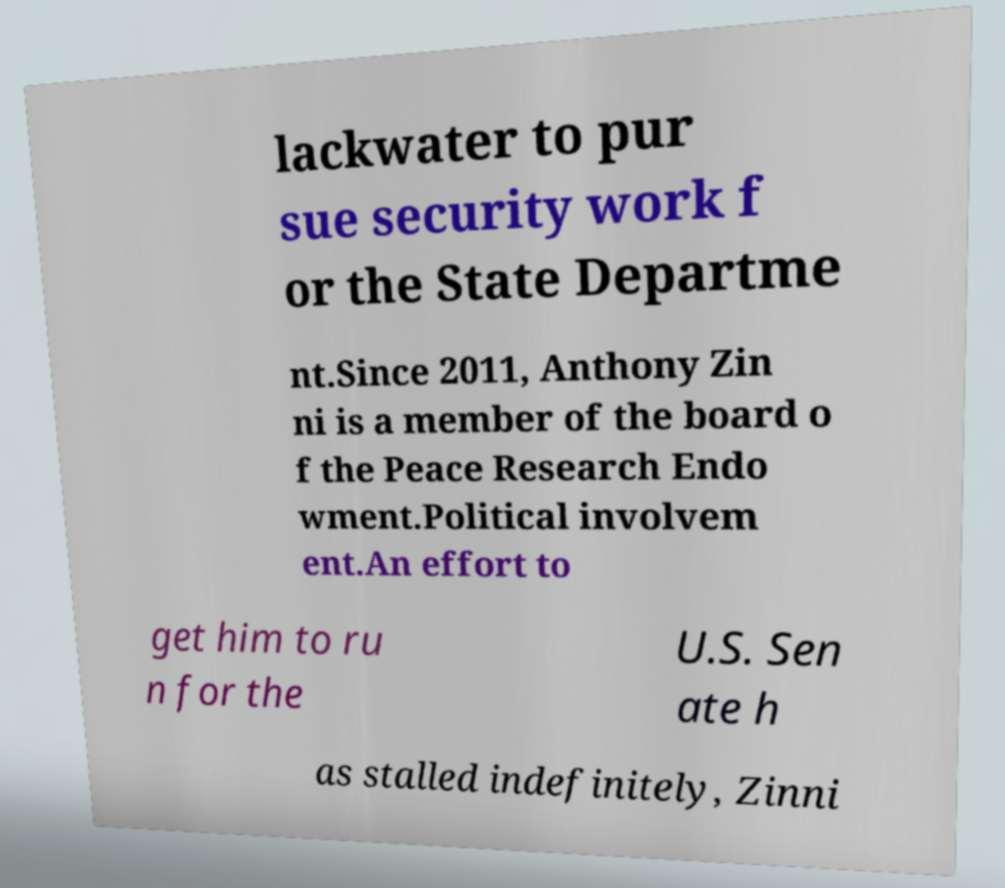I need the written content from this picture converted into text. Can you do that? lackwater to pur sue security work f or the State Departme nt.Since 2011, Anthony Zin ni is a member of the board o f the Peace Research Endo wment.Political involvem ent.An effort to get him to ru n for the U.S. Sen ate h as stalled indefinitely, Zinni 